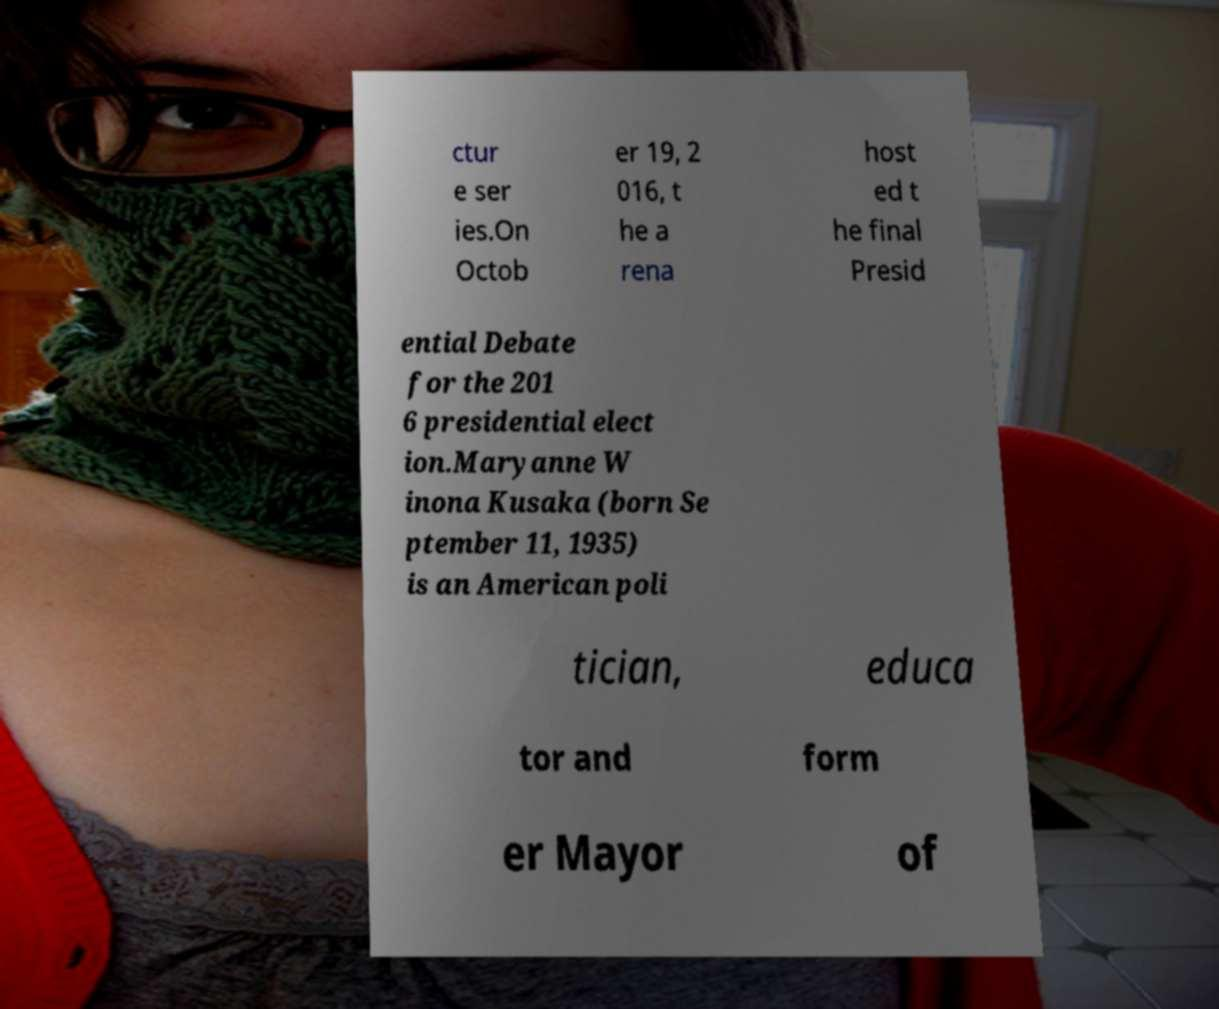Could you assist in decoding the text presented in this image and type it out clearly? ctur e ser ies.On Octob er 19, 2 016, t he a rena host ed t he final Presid ential Debate for the 201 6 presidential elect ion.Maryanne W inona Kusaka (born Se ptember 11, 1935) is an American poli tician, educa tor and form er Mayor of 